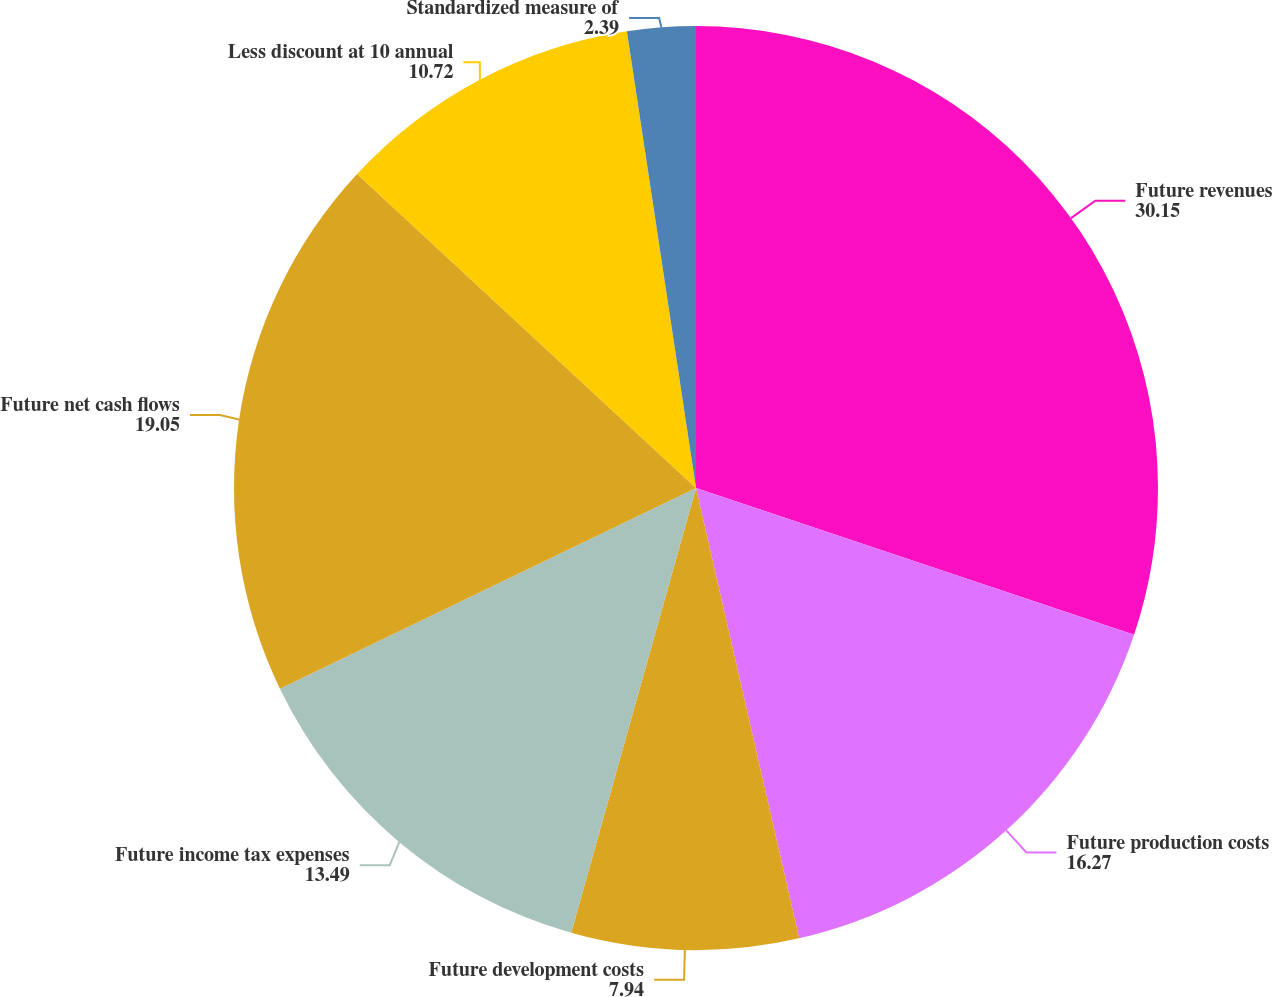<chart> <loc_0><loc_0><loc_500><loc_500><pie_chart><fcel>Future revenues<fcel>Future production costs<fcel>Future development costs<fcel>Future income tax expenses<fcel>Future net cash flows<fcel>Less discount at 10 annual<fcel>Standardized measure of<nl><fcel>30.15%<fcel>16.27%<fcel>7.94%<fcel>13.49%<fcel>19.05%<fcel>10.72%<fcel>2.39%<nl></chart> 